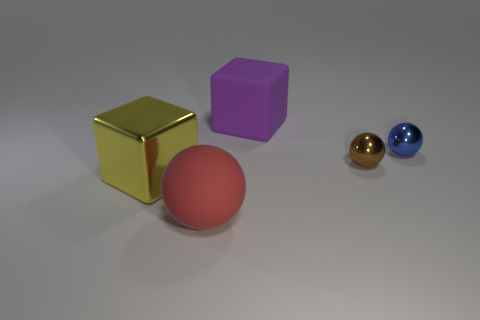Are there any purple rubber things of the same size as the yellow cube?
Provide a succinct answer. Yes. There is a big matte thing right of the large sphere; is it the same color as the shiny cube?
Your answer should be very brief. No. What number of objects are either large purple blocks or yellow metal blocks?
Your response must be concise. 2. Do the object that is in front of the shiny cube and the yellow metallic object have the same size?
Keep it short and to the point. Yes. How big is the metallic object that is both on the left side of the tiny blue thing and right of the yellow metallic thing?
Give a very brief answer. Small. How many other things are there of the same shape as the red matte thing?
Give a very brief answer. 2. How many other objects are the same material as the red sphere?
Give a very brief answer. 1. What size is the blue thing that is the same shape as the red object?
Keep it short and to the point. Small. What is the color of the object that is both behind the tiny brown ball and in front of the purple object?
Offer a terse response. Blue. How many things are tiny spheres to the left of the tiny blue shiny object or purple objects?
Your answer should be compact. 2. 